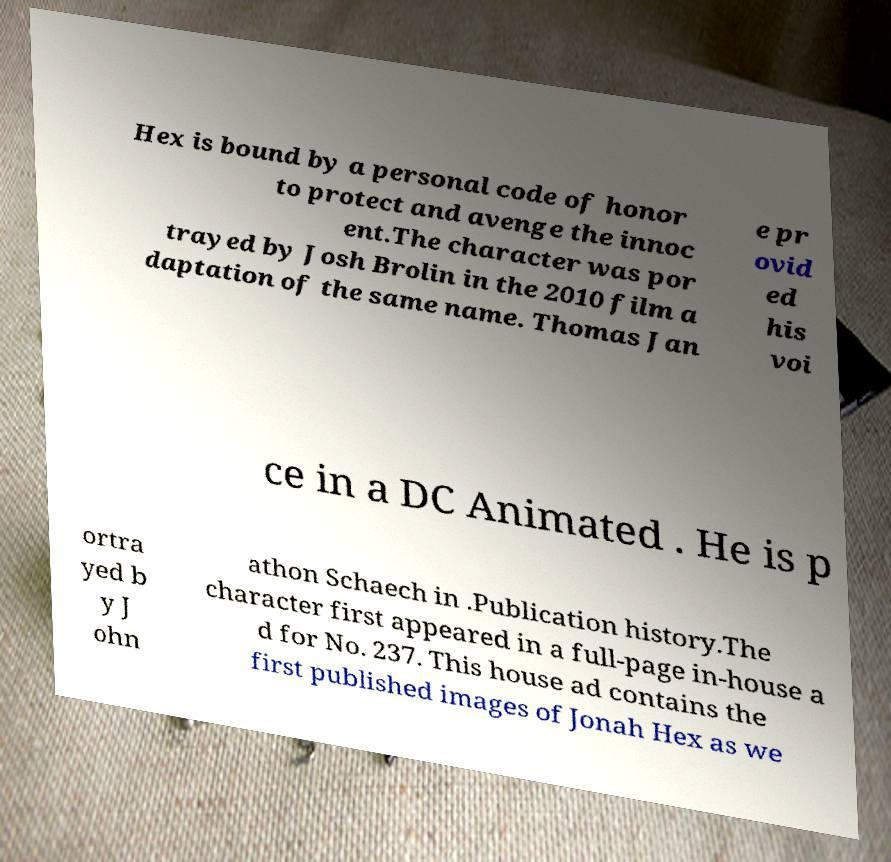Could you assist in decoding the text presented in this image and type it out clearly? Hex is bound by a personal code of honor to protect and avenge the innoc ent.The character was por trayed by Josh Brolin in the 2010 film a daptation of the same name. Thomas Jan e pr ovid ed his voi ce in a DC Animated . He is p ortra yed b y J ohn athon Schaech in .Publication history.The character first appeared in a full-page in-house a d for No. 237. This house ad contains the first published images of Jonah Hex as we 